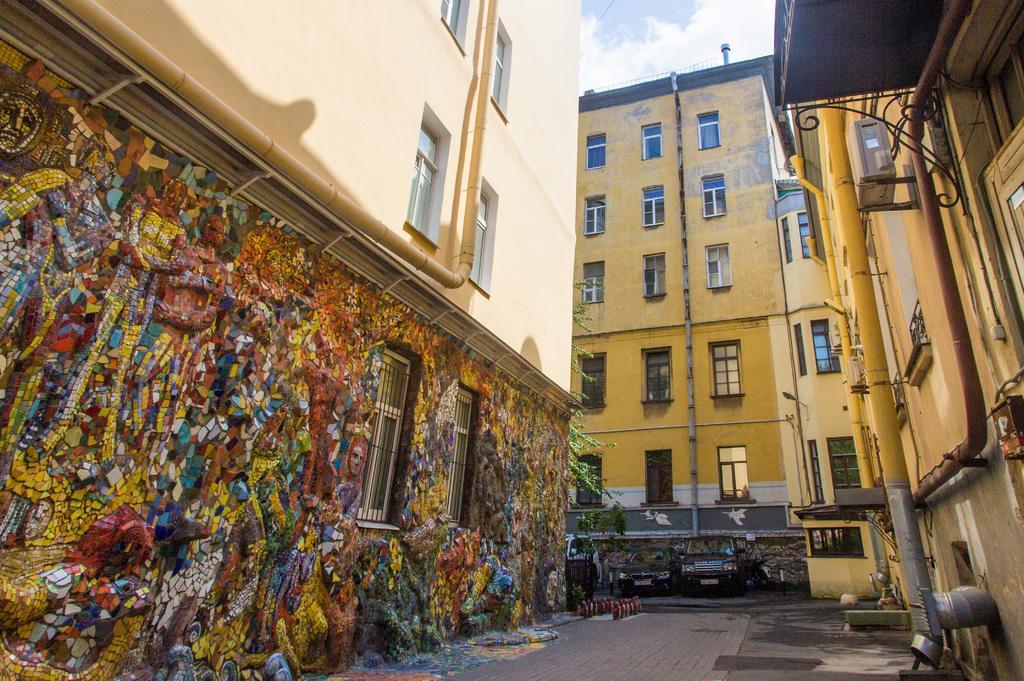Can you describe this image briefly? In this picture we can see some buildings, there are some vehicles which are parked and top of the picture there is clear sky. 